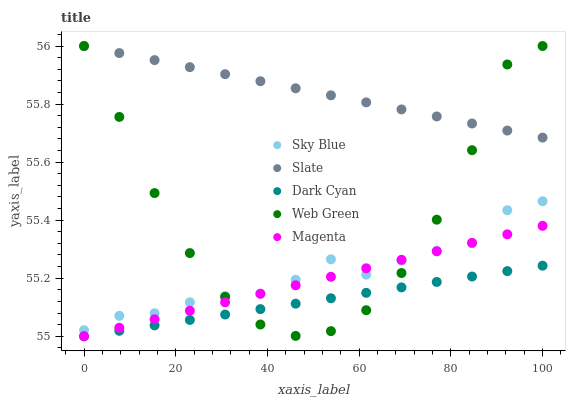Does Dark Cyan have the minimum area under the curve?
Answer yes or no. Yes. Does Slate have the maximum area under the curve?
Answer yes or no. Yes. Does Sky Blue have the minimum area under the curve?
Answer yes or no. No. Does Sky Blue have the maximum area under the curve?
Answer yes or no. No. Is Magenta the smoothest?
Answer yes or no. Yes. Is Web Green the roughest?
Answer yes or no. Yes. Is Sky Blue the smoothest?
Answer yes or no. No. Is Sky Blue the roughest?
Answer yes or no. No. Does Dark Cyan have the lowest value?
Answer yes or no. Yes. Does Sky Blue have the lowest value?
Answer yes or no. No. Does Web Green have the highest value?
Answer yes or no. Yes. Does Sky Blue have the highest value?
Answer yes or no. No. Is Dark Cyan less than Slate?
Answer yes or no. Yes. Is Slate greater than Dark Cyan?
Answer yes or no. Yes. Does Sky Blue intersect Magenta?
Answer yes or no. Yes. Is Sky Blue less than Magenta?
Answer yes or no. No. Is Sky Blue greater than Magenta?
Answer yes or no. No. Does Dark Cyan intersect Slate?
Answer yes or no. No. 